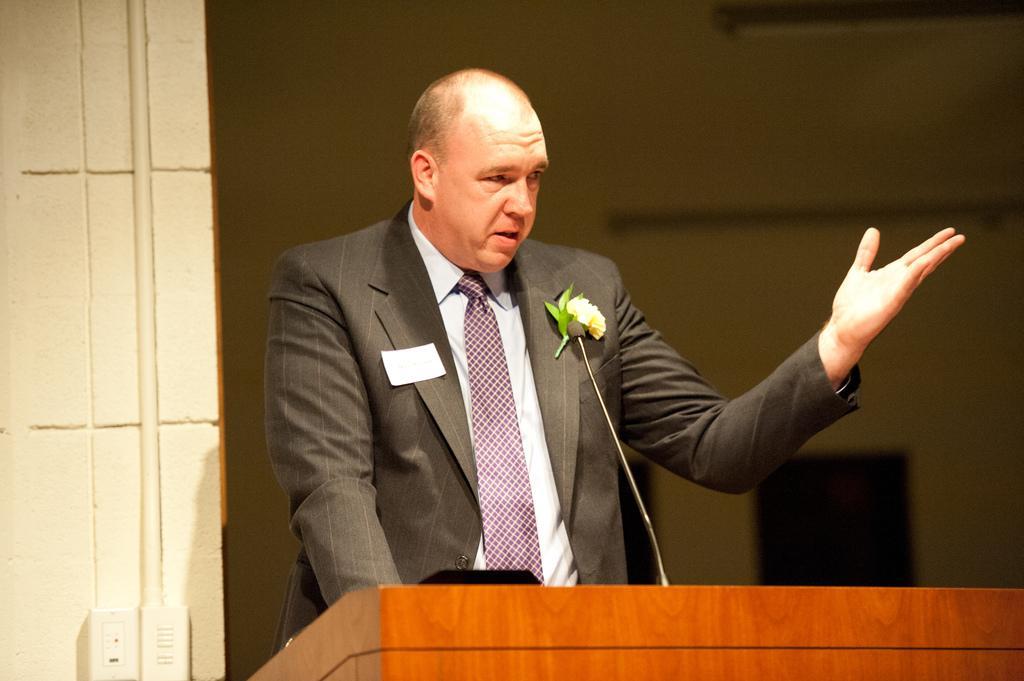Please provide a concise description of this image. Here in this picture we can see a person standing over a place in a black colored suit on him and speaking something in the microphone present in front of him on the speech desk over there and we can see an ID card and a flower on his coat over there. 